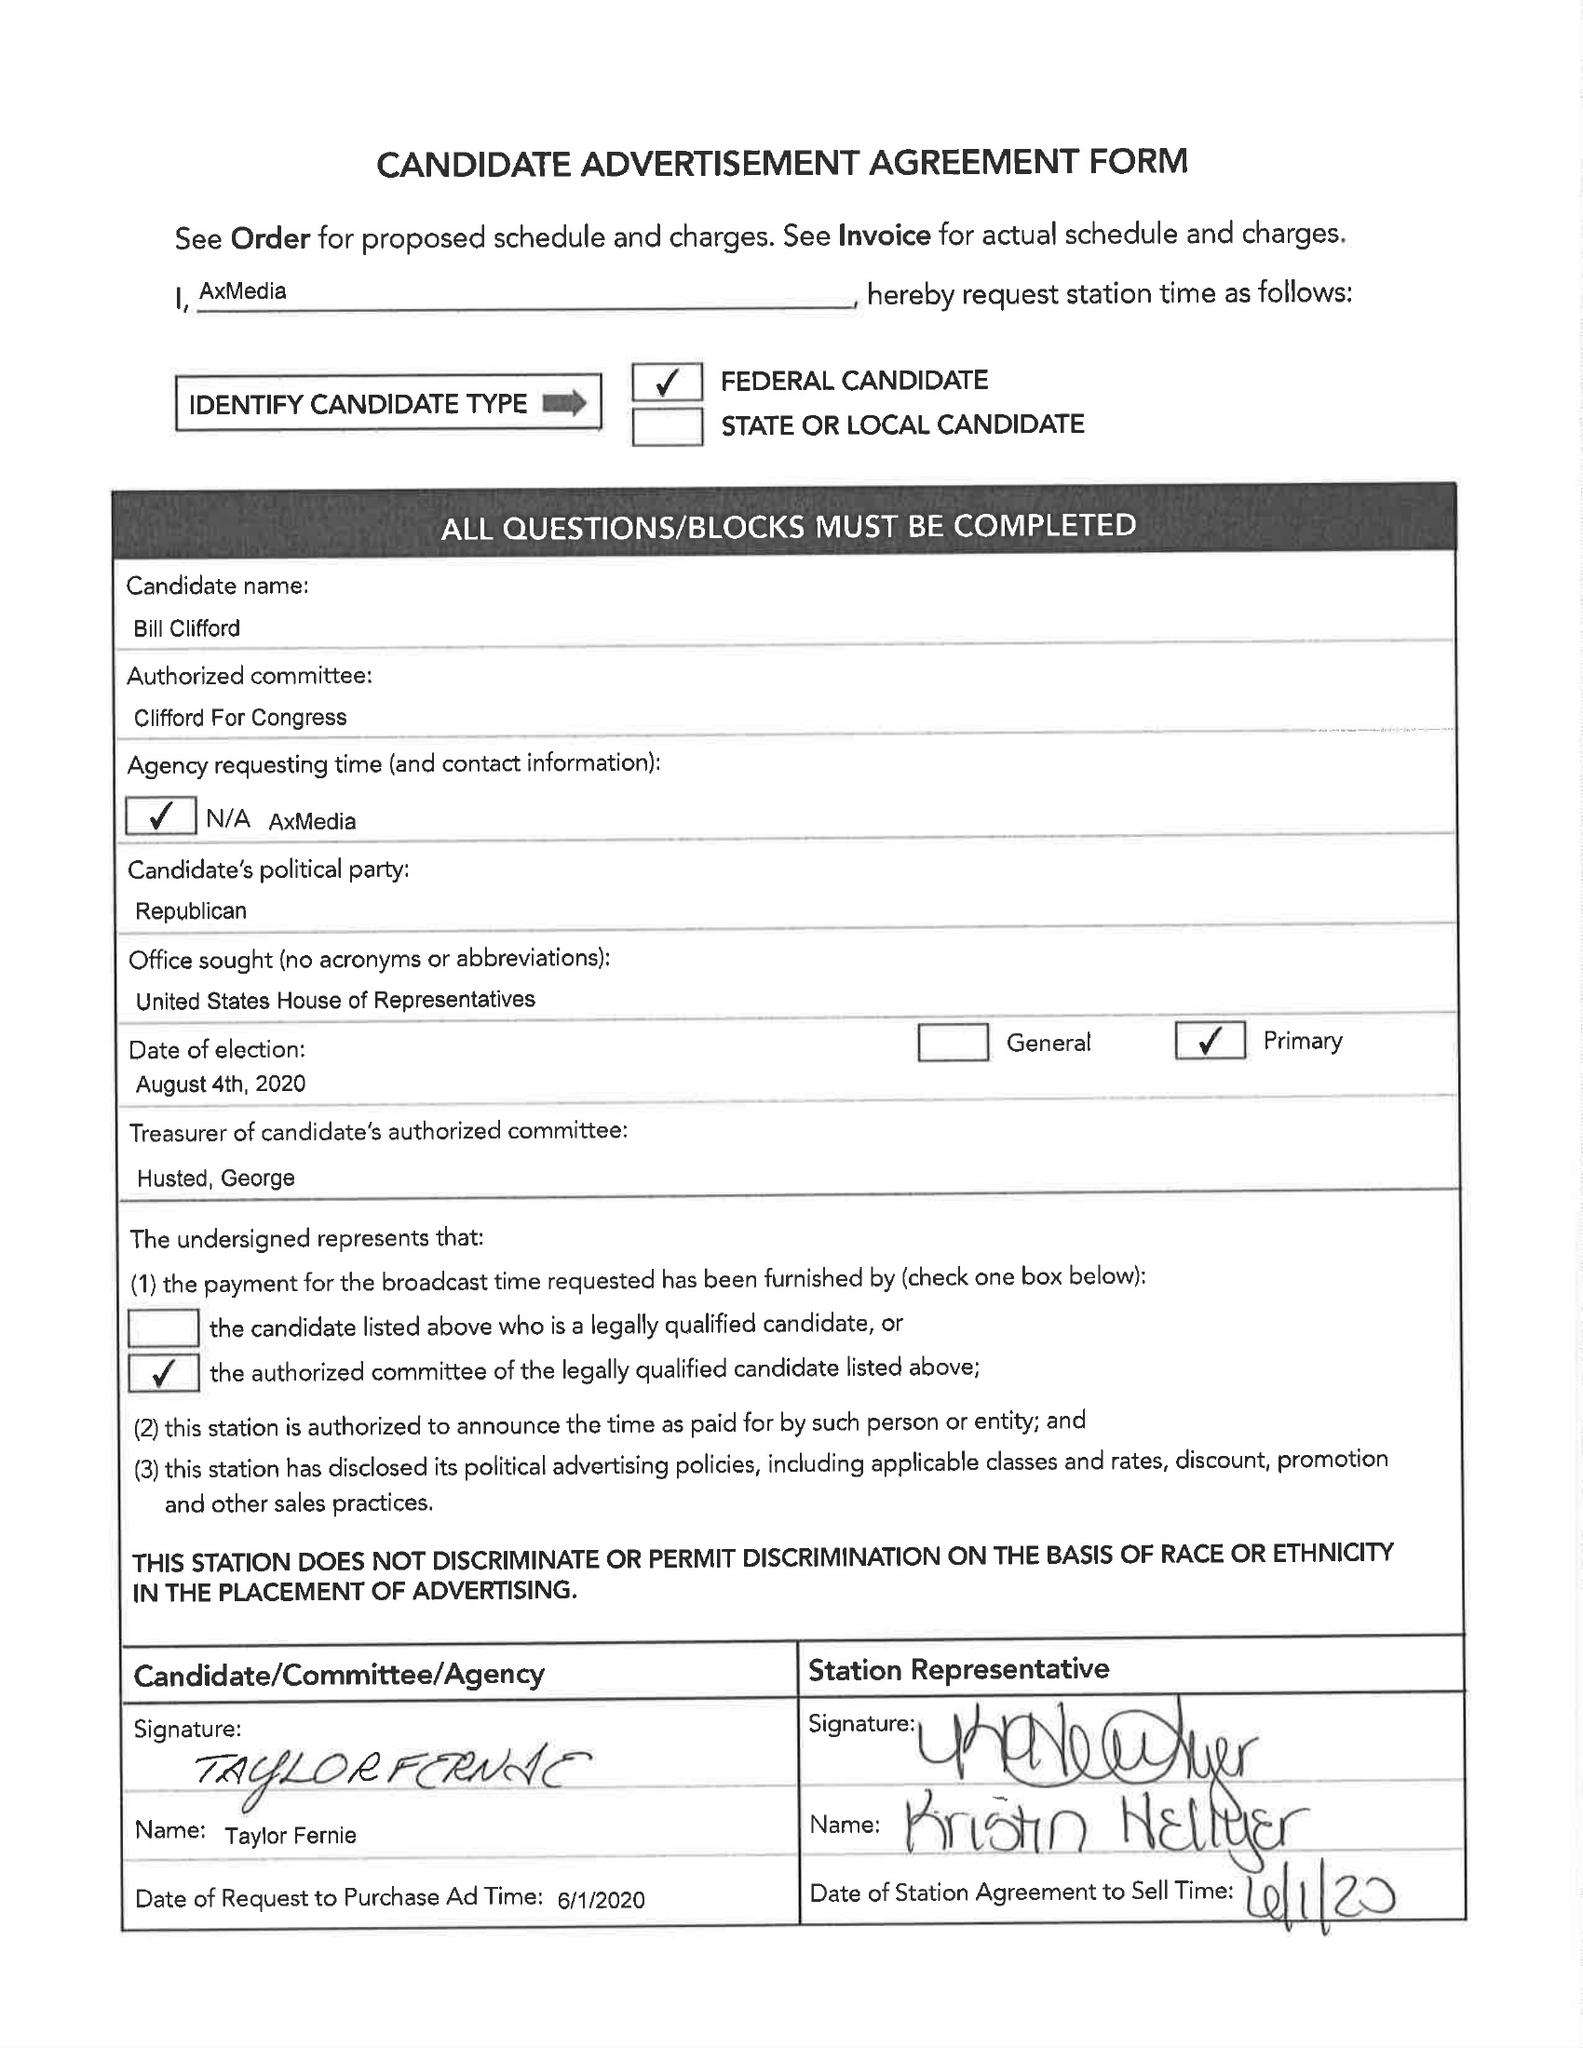What is the value for the contract_num?
Answer the question using a single word or phrase. 117402 